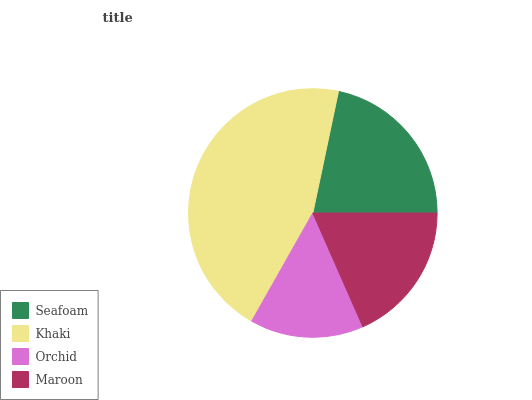Is Orchid the minimum?
Answer yes or no. Yes. Is Khaki the maximum?
Answer yes or no. Yes. Is Khaki the minimum?
Answer yes or no. No. Is Orchid the maximum?
Answer yes or no. No. Is Khaki greater than Orchid?
Answer yes or no. Yes. Is Orchid less than Khaki?
Answer yes or no. Yes. Is Orchid greater than Khaki?
Answer yes or no. No. Is Khaki less than Orchid?
Answer yes or no. No. Is Seafoam the high median?
Answer yes or no. Yes. Is Maroon the low median?
Answer yes or no. Yes. Is Maroon the high median?
Answer yes or no. No. Is Khaki the low median?
Answer yes or no. No. 